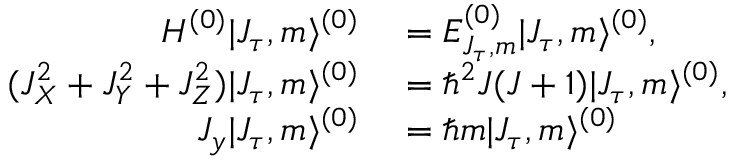Convert formula to latex. <formula><loc_0><loc_0><loc_500><loc_500>\begin{array} { r l } { H ^ { ( 0 ) } | J _ { \tau } , m \rangle ^ { ( 0 ) } } & = E _ { J _ { \tau } , m } ^ { ( 0 ) } | J _ { \tau } , m \rangle ^ { ( 0 ) } , } \\ { ( J _ { X } ^ { 2 } + J _ { Y } ^ { 2 } + J _ { Z } ^ { 2 } ) | J _ { \tau } , m \rangle ^ { ( 0 ) } } & = \hbar { ^ } { 2 } J ( J + 1 ) | J _ { \tau } , m \rangle ^ { ( 0 ) } , } \\ { J _ { y } | J _ { \tau } , m \rangle ^ { ( 0 ) } } & = \hbar { m } | J _ { \tau } , m \rangle ^ { ( 0 ) } } \end{array}</formula> 